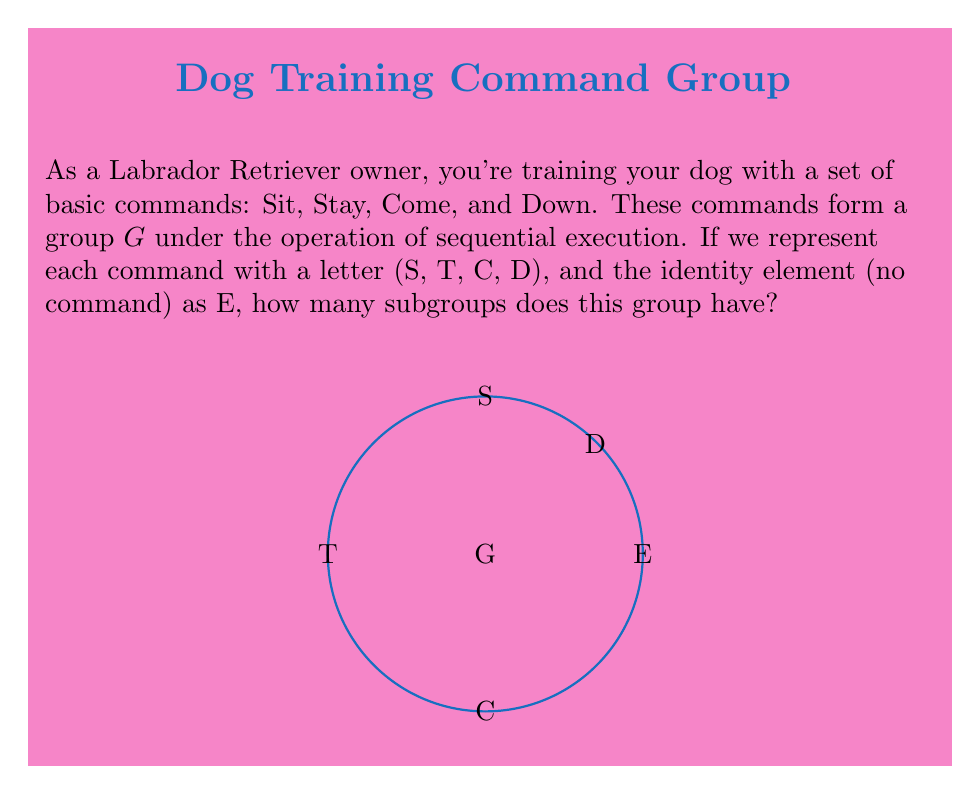Solve this math problem. Let's approach this step-by-step:

1) First, we need to understand the structure of the group. The group $G$ has 5 elements: $\{E, S, T, C, D\}$.

2) The order of the group $|G| = 5$.

3) Since 5 is a prime number, we know from Lagrange's theorem that the only possible orders for subgroups are 1 and 5.

4) There is always a trivial subgroup $\{E\}$ of order 1.

5) The entire group $G$ itself is also a subgroup of order 5.

6) For any group of prime order, there are no proper non-trivial subgroups.

7) Therefore, the only subgroups are $\{E\}$ and $G$ itself.

8) We can confirm this by noting that each non-identity element generates the entire group:
   $\langle S \rangle = \langle T \rangle = \langle C \rangle = \langle D \rangle = G$

9) Counting the subgroups: We have 2 subgroups in total.
Answer: 2 